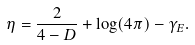Convert formula to latex. <formula><loc_0><loc_0><loc_500><loc_500>\eta = \frac { 2 } { 4 - D } + \log ( 4 \pi ) - \gamma _ { E } .</formula> 